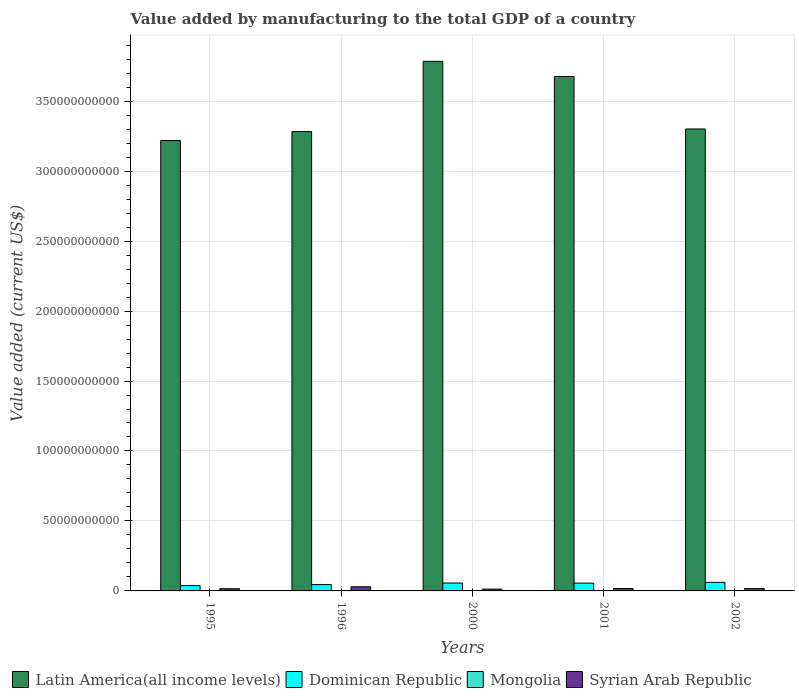How many groups of bars are there?
Provide a short and direct response. 5. What is the label of the 3rd group of bars from the left?
Offer a terse response. 2000. In how many cases, is the number of bars for a given year not equal to the number of legend labels?
Offer a very short reply. 0. What is the value added by manufacturing to the total GDP in Latin America(all income levels) in 1996?
Keep it short and to the point. 3.28e+11. Across all years, what is the maximum value added by manufacturing to the total GDP in Dominican Republic?
Your answer should be very brief. 6.13e+09. Across all years, what is the minimum value added by manufacturing to the total GDP in Syrian Arab Republic?
Provide a short and direct response. 1.29e+09. In which year was the value added by manufacturing to the total GDP in Latin America(all income levels) maximum?
Provide a short and direct response. 2000. In which year was the value added by manufacturing to the total GDP in Dominican Republic minimum?
Offer a terse response. 1995. What is the total value added by manufacturing to the total GDP in Latin America(all income levels) in the graph?
Make the answer very short. 1.73e+12. What is the difference between the value added by manufacturing to the total GDP in Mongolia in 1996 and that in 2001?
Ensure brevity in your answer.  -1.30e+06. What is the difference between the value added by manufacturing to the total GDP in Mongolia in 2000 and the value added by manufacturing to the total GDP in Syrian Arab Republic in 2001?
Your response must be concise. -1.64e+09. What is the average value added by manufacturing to the total GDP in Syrian Arab Republic per year?
Ensure brevity in your answer.  1.84e+09. In the year 1995, what is the difference between the value added by manufacturing to the total GDP in Syrian Arab Republic and value added by manufacturing to the total GDP in Latin America(all income levels)?
Offer a very short reply. -3.20e+11. In how many years, is the value added by manufacturing to the total GDP in Latin America(all income levels) greater than 90000000000 US$?
Keep it short and to the point. 5. What is the ratio of the value added by manufacturing to the total GDP in Syrian Arab Republic in 1996 to that in 2001?
Provide a succinct answer. 1.74. Is the difference between the value added by manufacturing to the total GDP in Syrian Arab Republic in 2001 and 2002 greater than the difference between the value added by manufacturing to the total GDP in Latin America(all income levels) in 2001 and 2002?
Your response must be concise. No. What is the difference between the highest and the second highest value added by manufacturing to the total GDP in Latin America(all income levels)?
Give a very brief answer. 1.08e+1. What is the difference between the highest and the lowest value added by manufacturing to the total GDP in Latin America(all income levels)?
Your answer should be compact. 5.66e+1. In how many years, is the value added by manufacturing to the total GDP in Dominican Republic greater than the average value added by manufacturing to the total GDP in Dominican Republic taken over all years?
Make the answer very short. 3. What does the 2nd bar from the left in 2001 represents?
Offer a very short reply. Dominican Republic. What does the 4th bar from the right in 1996 represents?
Make the answer very short. Latin America(all income levels). Are all the bars in the graph horizontal?
Ensure brevity in your answer.  No. How many years are there in the graph?
Offer a terse response. 5. What is the difference between two consecutive major ticks on the Y-axis?
Make the answer very short. 5.00e+1. Does the graph contain any zero values?
Your answer should be compact. No. How many legend labels are there?
Your response must be concise. 4. What is the title of the graph?
Provide a short and direct response. Value added by manufacturing to the total GDP of a country. What is the label or title of the Y-axis?
Provide a succinct answer. Value added (current US$). What is the Value added (current US$) of Latin America(all income levels) in 1995?
Your response must be concise. 3.22e+11. What is the Value added (current US$) of Dominican Republic in 1995?
Offer a terse response. 3.82e+09. What is the Value added (current US$) of Mongolia in 1995?
Your response must be concise. 2.51e+08. What is the Value added (current US$) in Syrian Arab Republic in 1995?
Keep it short and to the point. 1.57e+09. What is the Value added (current US$) of Latin America(all income levels) in 1996?
Provide a succinct answer. 3.28e+11. What is the Value added (current US$) of Dominican Republic in 1996?
Ensure brevity in your answer.  4.51e+09. What is the Value added (current US$) in Mongolia in 1996?
Provide a short and direct response. 1.03e+08. What is the Value added (current US$) in Syrian Arab Republic in 1996?
Offer a very short reply. 2.97e+09. What is the Value added (current US$) of Latin America(all income levels) in 2000?
Provide a short and direct response. 3.78e+11. What is the Value added (current US$) in Dominican Republic in 2000?
Provide a succinct answer. 5.63e+09. What is the Value added (current US$) in Mongolia in 2000?
Provide a short and direct response. 7.62e+07. What is the Value added (current US$) in Syrian Arab Republic in 2000?
Provide a succinct answer. 1.29e+09. What is the Value added (current US$) in Latin America(all income levels) in 2001?
Offer a terse response. 3.68e+11. What is the Value added (current US$) of Dominican Republic in 2001?
Provide a succinct answer. 5.58e+09. What is the Value added (current US$) in Mongolia in 2001?
Provide a succinct answer. 1.05e+08. What is the Value added (current US$) of Syrian Arab Republic in 2001?
Your answer should be compact. 1.71e+09. What is the Value added (current US$) of Latin America(all income levels) in 2002?
Offer a very short reply. 3.30e+11. What is the Value added (current US$) of Dominican Republic in 2002?
Offer a very short reply. 6.13e+09. What is the Value added (current US$) in Mongolia in 2002?
Provide a succinct answer. 8.93e+07. What is the Value added (current US$) of Syrian Arab Republic in 2002?
Give a very brief answer. 1.65e+09. Across all years, what is the maximum Value added (current US$) of Latin America(all income levels)?
Offer a terse response. 3.78e+11. Across all years, what is the maximum Value added (current US$) of Dominican Republic?
Your answer should be very brief. 6.13e+09. Across all years, what is the maximum Value added (current US$) of Mongolia?
Your answer should be very brief. 2.51e+08. Across all years, what is the maximum Value added (current US$) of Syrian Arab Republic?
Make the answer very short. 2.97e+09. Across all years, what is the minimum Value added (current US$) in Latin America(all income levels)?
Keep it short and to the point. 3.22e+11. Across all years, what is the minimum Value added (current US$) of Dominican Republic?
Your answer should be compact. 3.82e+09. Across all years, what is the minimum Value added (current US$) of Mongolia?
Your answer should be very brief. 7.62e+07. Across all years, what is the minimum Value added (current US$) in Syrian Arab Republic?
Offer a terse response. 1.29e+09. What is the total Value added (current US$) of Latin America(all income levels) in the graph?
Keep it short and to the point. 1.73e+12. What is the total Value added (current US$) in Dominican Republic in the graph?
Ensure brevity in your answer.  2.57e+1. What is the total Value added (current US$) in Mongolia in the graph?
Keep it short and to the point. 6.24e+08. What is the total Value added (current US$) in Syrian Arab Republic in the graph?
Your answer should be very brief. 9.20e+09. What is the difference between the Value added (current US$) of Latin America(all income levels) in 1995 and that in 1996?
Your answer should be compact. -6.43e+09. What is the difference between the Value added (current US$) in Dominican Republic in 1995 and that in 1996?
Provide a succinct answer. -6.84e+08. What is the difference between the Value added (current US$) in Mongolia in 1995 and that in 1996?
Provide a short and direct response. 1.48e+08. What is the difference between the Value added (current US$) in Syrian Arab Republic in 1995 and that in 1996?
Make the answer very short. -1.40e+09. What is the difference between the Value added (current US$) of Latin America(all income levels) in 1995 and that in 2000?
Ensure brevity in your answer.  -5.66e+1. What is the difference between the Value added (current US$) of Dominican Republic in 1995 and that in 2000?
Give a very brief answer. -1.81e+09. What is the difference between the Value added (current US$) of Mongolia in 1995 and that in 2000?
Make the answer very short. 1.75e+08. What is the difference between the Value added (current US$) of Syrian Arab Republic in 1995 and that in 2000?
Offer a terse response. 2.88e+08. What is the difference between the Value added (current US$) of Latin America(all income levels) in 1995 and that in 2001?
Give a very brief answer. -4.58e+1. What is the difference between the Value added (current US$) of Dominican Republic in 1995 and that in 2001?
Your answer should be very brief. -1.75e+09. What is the difference between the Value added (current US$) of Mongolia in 1995 and that in 2001?
Keep it short and to the point. 1.46e+08. What is the difference between the Value added (current US$) of Syrian Arab Republic in 1995 and that in 2001?
Provide a short and direct response. -1.39e+08. What is the difference between the Value added (current US$) of Latin America(all income levels) in 1995 and that in 2002?
Your answer should be very brief. -8.28e+09. What is the difference between the Value added (current US$) of Dominican Republic in 1995 and that in 2002?
Provide a short and direct response. -2.30e+09. What is the difference between the Value added (current US$) in Mongolia in 1995 and that in 2002?
Give a very brief answer. 1.62e+08. What is the difference between the Value added (current US$) of Syrian Arab Republic in 1995 and that in 2002?
Provide a succinct answer. -7.89e+07. What is the difference between the Value added (current US$) of Latin America(all income levels) in 1996 and that in 2000?
Give a very brief answer. -5.02e+1. What is the difference between the Value added (current US$) in Dominican Republic in 1996 and that in 2000?
Ensure brevity in your answer.  -1.13e+09. What is the difference between the Value added (current US$) of Mongolia in 1996 and that in 2000?
Offer a very short reply. 2.71e+07. What is the difference between the Value added (current US$) of Syrian Arab Republic in 1996 and that in 2000?
Your answer should be very brief. 1.69e+09. What is the difference between the Value added (current US$) of Latin America(all income levels) in 1996 and that in 2001?
Ensure brevity in your answer.  -3.94e+1. What is the difference between the Value added (current US$) in Dominican Republic in 1996 and that in 2001?
Provide a succinct answer. -1.07e+09. What is the difference between the Value added (current US$) in Mongolia in 1996 and that in 2001?
Your answer should be compact. -1.30e+06. What is the difference between the Value added (current US$) in Syrian Arab Republic in 1996 and that in 2001?
Make the answer very short. 1.26e+09. What is the difference between the Value added (current US$) of Latin America(all income levels) in 1996 and that in 2002?
Your response must be concise. -1.86e+09. What is the difference between the Value added (current US$) in Dominican Republic in 1996 and that in 2002?
Offer a very short reply. -1.62e+09. What is the difference between the Value added (current US$) in Mongolia in 1996 and that in 2002?
Provide a short and direct response. 1.40e+07. What is the difference between the Value added (current US$) in Syrian Arab Republic in 1996 and that in 2002?
Keep it short and to the point. 1.32e+09. What is the difference between the Value added (current US$) of Latin America(all income levels) in 2000 and that in 2001?
Your response must be concise. 1.08e+1. What is the difference between the Value added (current US$) in Dominican Republic in 2000 and that in 2001?
Provide a short and direct response. 5.89e+07. What is the difference between the Value added (current US$) in Mongolia in 2000 and that in 2001?
Your response must be concise. -2.84e+07. What is the difference between the Value added (current US$) of Syrian Arab Republic in 2000 and that in 2001?
Ensure brevity in your answer.  -4.27e+08. What is the difference between the Value added (current US$) in Latin America(all income levels) in 2000 and that in 2002?
Your answer should be very brief. 4.83e+1. What is the difference between the Value added (current US$) of Dominican Republic in 2000 and that in 2002?
Provide a short and direct response. -4.93e+08. What is the difference between the Value added (current US$) of Mongolia in 2000 and that in 2002?
Provide a succinct answer. -1.31e+07. What is the difference between the Value added (current US$) in Syrian Arab Republic in 2000 and that in 2002?
Your answer should be very brief. -3.67e+08. What is the difference between the Value added (current US$) in Latin America(all income levels) in 2001 and that in 2002?
Offer a terse response. 3.75e+1. What is the difference between the Value added (current US$) of Dominican Republic in 2001 and that in 2002?
Make the answer very short. -5.52e+08. What is the difference between the Value added (current US$) of Mongolia in 2001 and that in 2002?
Provide a short and direct response. 1.53e+07. What is the difference between the Value added (current US$) in Syrian Arab Republic in 2001 and that in 2002?
Your answer should be very brief. 6.00e+07. What is the difference between the Value added (current US$) of Latin America(all income levels) in 1995 and the Value added (current US$) of Dominican Republic in 1996?
Offer a terse response. 3.17e+11. What is the difference between the Value added (current US$) in Latin America(all income levels) in 1995 and the Value added (current US$) in Mongolia in 1996?
Give a very brief answer. 3.22e+11. What is the difference between the Value added (current US$) in Latin America(all income levels) in 1995 and the Value added (current US$) in Syrian Arab Republic in 1996?
Offer a terse response. 3.19e+11. What is the difference between the Value added (current US$) in Dominican Republic in 1995 and the Value added (current US$) in Mongolia in 1996?
Your answer should be very brief. 3.72e+09. What is the difference between the Value added (current US$) of Dominican Republic in 1995 and the Value added (current US$) of Syrian Arab Republic in 1996?
Your answer should be very brief. 8.49e+08. What is the difference between the Value added (current US$) in Mongolia in 1995 and the Value added (current US$) in Syrian Arab Republic in 1996?
Provide a succinct answer. -2.72e+09. What is the difference between the Value added (current US$) in Latin America(all income levels) in 1995 and the Value added (current US$) in Dominican Republic in 2000?
Your answer should be compact. 3.16e+11. What is the difference between the Value added (current US$) in Latin America(all income levels) in 1995 and the Value added (current US$) in Mongolia in 2000?
Make the answer very short. 3.22e+11. What is the difference between the Value added (current US$) in Latin America(all income levels) in 1995 and the Value added (current US$) in Syrian Arab Republic in 2000?
Offer a very short reply. 3.21e+11. What is the difference between the Value added (current US$) in Dominican Republic in 1995 and the Value added (current US$) in Mongolia in 2000?
Offer a very short reply. 3.75e+09. What is the difference between the Value added (current US$) in Dominican Republic in 1995 and the Value added (current US$) in Syrian Arab Republic in 2000?
Make the answer very short. 2.54e+09. What is the difference between the Value added (current US$) in Mongolia in 1995 and the Value added (current US$) in Syrian Arab Republic in 2000?
Provide a short and direct response. -1.04e+09. What is the difference between the Value added (current US$) of Latin America(all income levels) in 1995 and the Value added (current US$) of Dominican Republic in 2001?
Offer a terse response. 3.16e+11. What is the difference between the Value added (current US$) in Latin America(all income levels) in 1995 and the Value added (current US$) in Mongolia in 2001?
Offer a terse response. 3.22e+11. What is the difference between the Value added (current US$) of Latin America(all income levels) in 1995 and the Value added (current US$) of Syrian Arab Republic in 2001?
Your answer should be compact. 3.20e+11. What is the difference between the Value added (current US$) of Dominican Republic in 1995 and the Value added (current US$) of Mongolia in 2001?
Make the answer very short. 3.72e+09. What is the difference between the Value added (current US$) of Dominican Republic in 1995 and the Value added (current US$) of Syrian Arab Republic in 2001?
Make the answer very short. 2.11e+09. What is the difference between the Value added (current US$) of Mongolia in 1995 and the Value added (current US$) of Syrian Arab Republic in 2001?
Provide a short and direct response. -1.46e+09. What is the difference between the Value added (current US$) of Latin America(all income levels) in 1995 and the Value added (current US$) of Dominican Republic in 2002?
Make the answer very short. 3.16e+11. What is the difference between the Value added (current US$) in Latin America(all income levels) in 1995 and the Value added (current US$) in Mongolia in 2002?
Your response must be concise. 3.22e+11. What is the difference between the Value added (current US$) in Latin America(all income levels) in 1995 and the Value added (current US$) in Syrian Arab Republic in 2002?
Make the answer very short. 3.20e+11. What is the difference between the Value added (current US$) in Dominican Republic in 1995 and the Value added (current US$) in Mongolia in 2002?
Your answer should be very brief. 3.73e+09. What is the difference between the Value added (current US$) in Dominican Republic in 1995 and the Value added (current US$) in Syrian Arab Republic in 2002?
Your answer should be very brief. 2.17e+09. What is the difference between the Value added (current US$) of Mongolia in 1995 and the Value added (current US$) of Syrian Arab Republic in 2002?
Keep it short and to the point. -1.40e+09. What is the difference between the Value added (current US$) of Latin America(all income levels) in 1996 and the Value added (current US$) of Dominican Republic in 2000?
Provide a short and direct response. 3.23e+11. What is the difference between the Value added (current US$) in Latin America(all income levels) in 1996 and the Value added (current US$) in Mongolia in 2000?
Your response must be concise. 3.28e+11. What is the difference between the Value added (current US$) in Latin America(all income levels) in 1996 and the Value added (current US$) in Syrian Arab Republic in 2000?
Keep it short and to the point. 3.27e+11. What is the difference between the Value added (current US$) in Dominican Republic in 1996 and the Value added (current US$) in Mongolia in 2000?
Keep it short and to the point. 4.43e+09. What is the difference between the Value added (current US$) of Dominican Republic in 1996 and the Value added (current US$) of Syrian Arab Republic in 2000?
Your answer should be compact. 3.22e+09. What is the difference between the Value added (current US$) in Mongolia in 1996 and the Value added (current US$) in Syrian Arab Republic in 2000?
Keep it short and to the point. -1.18e+09. What is the difference between the Value added (current US$) in Latin America(all income levels) in 1996 and the Value added (current US$) in Dominican Republic in 2001?
Your answer should be very brief. 3.23e+11. What is the difference between the Value added (current US$) in Latin America(all income levels) in 1996 and the Value added (current US$) in Mongolia in 2001?
Provide a succinct answer. 3.28e+11. What is the difference between the Value added (current US$) in Latin America(all income levels) in 1996 and the Value added (current US$) in Syrian Arab Republic in 2001?
Provide a short and direct response. 3.27e+11. What is the difference between the Value added (current US$) of Dominican Republic in 1996 and the Value added (current US$) of Mongolia in 2001?
Your answer should be compact. 4.40e+09. What is the difference between the Value added (current US$) of Dominican Republic in 1996 and the Value added (current US$) of Syrian Arab Republic in 2001?
Provide a short and direct response. 2.79e+09. What is the difference between the Value added (current US$) in Mongolia in 1996 and the Value added (current US$) in Syrian Arab Republic in 2001?
Your response must be concise. -1.61e+09. What is the difference between the Value added (current US$) in Latin America(all income levels) in 1996 and the Value added (current US$) in Dominican Republic in 2002?
Make the answer very short. 3.22e+11. What is the difference between the Value added (current US$) in Latin America(all income levels) in 1996 and the Value added (current US$) in Mongolia in 2002?
Offer a very short reply. 3.28e+11. What is the difference between the Value added (current US$) in Latin America(all income levels) in 1996 and the Value added (current US$) in Syrian Arab Republic in 2002?
Keep it short and to the point. 3.27e+11. What is the difference between the Value added (current US$) of Dominican Republic in 1996 and the Value added (current US$) of Mongolia in 2002?
Offer a terse response. 4.42e+09. What is the difference between the Value added (current US$) of Dominican Republic in 1996 and the Value added (current US$) of Syrian Arab Republic in 2002?
Provide a succinct answer. 2.85e+09. What is the difference between the Value added (current US$) in Mongolia in 1996 and the Value added (current US$) in Syrian Arab Republic in 2002?
Keep it short and to the point. -1.55e+09. What is the difference between the Value added (current US$) of Latin America(all income levels) in 2000 and the Value added (current US$) of Dominican Republic in 2001?
Keep it short and to the point. 3.73e+11. What is the difference between the Value added (current US$) in Latin America(all income levels) in 2000 and the Value added (current US$) in Mongolia in 2001?
Offer a very short reply. 3.78e+11. What is the difference between the Value added (current US$) of Latin America(all income levels) in 2000 and the Value added (current US$) of Syrian Arab Republic in 2001?
Ensure brevity in your answer.  3.77e+11. What is the difference between the Value added (current US$) in Dominican Republic in 2000 and the Value added (current US$) in Mongolia in 2001?
Your response must be concise. 5.53e+09. What is the difference between the Value added (current US$) in Dominican Republic in 2000 and the Value added (current US$) in Syrian Arab Republic in 2001?
Offer a terse response. 3.92e+09. What is the difference between the Value added (current US$) in Mongolia in 2000 and the Value added (current US$) in Syrian Arab Republic in 2001?
Give a very brief answer. -1.64e+09. What is the difference between the Value added (current US$) in Latin America(all income levels) in 2000 and the Value added (current US$) in Dominican Republic in 2002?
Your answer should be very brief. 3.72e+11. What is the difference between the Value added (current US$) in Latin America(all income levels) in 2000 and the Value added (current US$) in Mongolia in 2002?
Provide a succinct answer. 3.78e+11. What is the difference between the Value added (current US$) of Latin America(all income levels) in 2000 and the Value added (current US$) of Syrian Arab Republic in 2002?
Your response must be concise. 3.77e+11. What is the difference between the Value added (current US$) of Dominican Republic in 2000 and the Value added (current US$) of Mongolia in 2002?
Ensure brevity in your answer.  5.55e+09. What is the difference between the Value added (current US$) in Dominican Republic in 2000 and the Value added (current US$) in Syrian Arab Republic in 2002?
Ensure brevity in your answer.  3.98e+09. What is the difference between the Value added (current US$) in Mongolia in 2000 and the Value added (current US$) in Syrian Arab Republic in 2002?
Your answer should be compact. -1.58e+09. What is the difference between the Value added (current US$) in Latin America(all income levels) in 2001 and the Value added (current US$) in Dominican Republic in 2002?
Provide a succinct answer. 3.61e+11. What is the difference between the Value added (current US$) in Latin America(all income levels) in 2001 and the Value added (current US$) in Mongolia in 2002?
Your answer should be very brief. 3.68e+11. What is the difference between the Value added (current US$) in Latin America(all income levels) in 2001 and the Value added (current US$) in Syrian Arab Republic in 2002?
Give a very brief answer. 3.66e+11. What is the difference between the Value added (current US$) in Dominican Republic in 2001 and the Value added (current US$) in Mongolia in 2002?
Make the answer very short. 5.49e+09. What is the difference between the Value added (current US$) of Dominican Republic in 2001 and the Value added (current US$) of Syrian Arab Republic in 2002?
Your answer should be compact. 3.92e+09. What is the difference between the Value added (current US$) in Mongolia in 2001 and the Value added (current US$) in Syrian Arab Republic in 2002?
Your response must be concise. -1.55e+09. What is the average Value added (current US$) in Latin America(all income levels) per year?
Your answer should be very brief. 3.45e+11. What is the average Value added (current US$) of Dominican Republic per year?
Ensure brevity in your answer.  5.13e+09. What is the average Value added (current US$) in Mongolia per year?
Your answer should be compact. 1.25e+08. What is the average Value added (current US$) of Syrian Arab Republic per year?
Give a very brief answer. 1.84e+09. In the year 1995, what is the difference between the Value added (current US$) of Latin America(all income levels) and Value added (current US$) of Dominican Republic?
Your response must be concise. 3.18e+11. In the year 1995, what is the difference between the Value added (current US$) of Latin America(all income levels) and Value added (current US$) of Mongolia?
Your response must be concise. 3.22e+11. In the year 1995, what is the difference between the Value added (current US$) in Latin America(all income levels) and Value added (current US$) in Syrian Arab Republic?
Provide a succinct answer. 3.20e+11. In the year 1995, what is the difference between the Value added (current US$) of Dominican Republic and Value added (current US$) of Mongolia?
Make the answer very short. 3.57e+09. In the year 1995, what is the difference between the Value added (current US$) in Dominican Republic and Value added (current US$) in Syrian Arab Republic?
Make the answer very short. 2.25e+09. In the year 1995, what is the difference between the Value added (current US$) of Mongolia and Value added (current US$) of Syrian Arab Republic?
Your answer should be very brief. -1.32e+09. In the year 1996, what is the difference between the Value added (current US$) in Latin America(all income levels) and Value added (current US$) in Dominican Republic?
Keep it short and to the point. 3.24e+11. In the year 1996, what is the difference between the Value added (current US$) in Latin America(all income levels) and Value added (current US$) in Mongolia?
Keep it short and to the point. 3.28e+11. In the year 1996, what is the difference between the Value added (current US$) of Latin America(all income levels) and Value added (current US$) of Syrian Arab Republic?
Offer a terse response. 3.25e+11. In the year 1996, what is the difference between the Value added (current US$) of Dominican Republic and Value added (current US$) of Mongolia?
Offer a terse response. 4.40e+09. In the year 1996, what is the difference between the Value added (current US$) in Dominican Republic and Value added (current US$) in Syrian Arab Republic?
Provide a succinct answer. 1.53e+09. In the year 1996, what is the difference between the Value added (current US$) in Mongolia and Value added (current US$) in Syrian Arab Republic?
Make the answer very short. -2.87e+09. In the year 2000, what is the difference between the Value added (current US$) of Latin America(all income levels) and Value added (current US$) of Dominican Republic?
Keep it short and to the point. 3.73e+11. In the year 2000, what is the difference between the Value added (current US$) in Latin America(all income levels) and Value added (current US$) in Mongolia?
Your answer should be compact. 3.78e+11. In the year 2000, what is the difference between the Value added (current US$) of Latin America(all income levels) and Value added (current US$) of Syrian Arab Republic?
Provide a short and direct response. 3.77e+11. In the year 2000, what is the difference between the Value added (current US$) in Dominican Republic and Value added (current US$) in Mongolia?
Provide a short and direct response. 5.56e+09. In the year 2000, what is the difference between the Value added (current US$) in Dominican Republic and Value added (current US$) in Syrian Arab Republic?
Give a very brief answer. 4.35e+09. In the year 2000, what is the difference between the Value added (current US$) of Mongolia and Value added (current US$) of Syrian Arab Republic?
Provide a succinct answer. -1.21e+09. In the year 2001, what is the difference between the Value added (current US$) of Latin America(all income levels) and Value added (current US$) of Dominican Republic?
Give a very brief answer. 3.62e+11. In the year 2001, what is the difference between the Value added (current US$) in Latin America(all income levels) and Value added (current US$) in Mongolia?
Ensure brevity in your answer.  3.68e+11. In the year 2001, what is the difference between the Value added (current US$) in Latin America(all income levels) and Value added (current US$) in Syrian Arab Republic?
Offer a terse response. 3.66e+11. In the year 2001, what is the difference between the Value added (current US$) in Dominican Republic and Value added (current US$) in Mongolia?
Provide a succinct answer. 5.47e+09. In the year 2001, what is the difference between the Value added (current US$) in Dominican Republic and Value added (current US$) in Syrian Arab Republic?
Keep it short and to the point. 3.86e+09. In the year 2001, what is the difference between the Value added (current US$) in Mongolia and Value added (current US$) in Syrian Arab Republic?
Your answer should be compact. -1.61e+09. In the year 2002, what is the difference between the Value added (current US$) of Latin America(all income levels) and Value added (current US$) of Dominican Republic?
Make the answer very short. 3.24e+11. In the year 2002, what is the difference between the Value added (current US$) in Latin America(all income levels) and Value added (current US$) in Mongolia?
Give a very brief answer. 3.30e+11. In the year 2002, what is the difference between the Value added (current US$) of Latin America(all income levels) and Value added (current US$) of Syrian Arab Republic?
Your response must be concise. 3.28e+11. In the year 2002, what is the difference between the Value added (current US$) of Dominican Republic and Value added (current US$) of Mongolia?
Your answer should be very brief. 6.04e+09. In the year 2002, what is the difference between the Value added (current US$) in Dominican Republic and Value added (current US$) in Syrian Arab Republic?
Offer a very short reply. 4.47e+09. In the year 2002, what is the difference between the Value added (current US$) of Mongolia and Value added (current US$) of Syrian Arab Republic?
Offer a very short reply. -1.56e+09. What is the ratio of the Value added (current US$) of Latin America(all income levels) in 1995 to that in 1996?
Keep it short and to the point. 0.98. What is the ratio of the Value added (current US$) of Dominican Republic in 1995 to that in 1996?
Provide a succinct answer. 0.85. What is the ratio of the Value added (current US$) in Mongolia in 1995 to that in 1996?
Make the answer very short. 2.43. What is the ratio of the Value added (current US$) in Syrian Arab Republic in 1995 to that in 1996?
Offer a very short reply. 0.53. What is the ratio of the Value added (current US$) of Latin America(all income levels) in 1995 to that in 2000?
Provide a succinct answer. 0.85. What is the ratio of the Value added (current US$) of Dominican Republic in 1995 to that in 2000?
Keep it short and to the point. 0.68. What is the ratio of the Value added (current US$) of Mongolia in 1995 to that in 2000?
Give a very brief answer. 3.29. What is the ratio of the Value added (current US$) in Syrian Arab Republic in 1995 to that in 2000?
Ensure brevity in your answer.  1.22. What is the ratio of the Value added (current US$) in Latin America(all income levels) in 1995 to that in 2001?
Your response must be concise. 0.88. What is the ratio of the Value added (current US$) in Dominican Republic in 1995 to that in 2001?
Give a very brief answer. 0.69. What is the ratio of the Value added (current US$) in Mongolia in 1995 to that in 2001?
Provide a short and direct response. 2.4. What is the ratio of the Value added (current US$) of Syrian Arab Republic in 1995 to that in 2001?
Provide a short and direct response. 0.92. What is the ratio of the Value added (current US$) in Latin America(all income levels) in 1995 to that in 2002?
Offer a terse response. 0.97. What is the ratio of the Value added (current US$) in Dominican Republic in 1995 to that in 2002?
Give a very brief answer. 0.62. What is the ratio of the Value added (current US$) of Mongolia in 1995 to that in 2002?
Make the answer very short. 2.81. What is the ratio of the Value added (current US$) of Syrian Arab Republic in 1995 to that in 2002?
Offer a terse response. 0.95. What is the ratio of the Value added (current US$) in Latin America(all income levels) in 1996 to that in 2000?
Your answer should be compact. 0.87. What is the ratio of the Value added (current US$) of Dominican Republic in 1996 to that in 2000?
Offer a very short reply. 0.8. What is the ratio of the Value added (current US$) in Mongolia in 1996 to that in 2000?
Give a very brief answer. 1.36. What is the ratio of the Value added (current US$) of Syrian Arab Republic in 1996 to that in 2000?
Provide a succinct answer. 2.31. What is the ratio of the Value added (current US$) in Latin America(all income levels) in 1996 to that in 2001?
Offer a very short reply. 0.89. What is the ratio of the Value added (current US$) of Dominican Republic in 1996 to that in 2001?
Your answer should be compact. 0.81. What is the ratio of the Value added (current US$) in Mongolia in 1996 to that in 2001?
Your answer should be very brief. 0.99. What is the ratio of the Value added (current US$) of Syrian Arab Republic in 1996 to that in 2001?
Make the answer very short. 1.74. What is the ratio of the Value added (current US$) in Dominican Republic in 1996 to that in 2002?
Ensure brevity in your answer.  0.74. What is the ratio of the Value added (current US$) of Mongolia in 1996 to that in 2002?
Ensure brevity in your answer.  1.16. What is the ratio of the Value added (current US$) in Syrian Arab Republic in 1996 to that in 2002?
Offer a very short reply. 1.8. What is the ratio of the Value added (current US$) of Latin America(all income levels) in 2000 to that in 2001?
Keep it short and to the point. 1.03. What is the ratio of the Value added (current US$) in Dominican Republic in 2000 to that in 2001?
Give a very brief answer. 1.01. What is the ratio of the Value added (current US$) of Mongolia in 2000 to that in 2001?
Make the answer very short. 0.73. What is the ratio of the Value added (current US$) of Syrian Arab Republic in 2000 to that in 2001?
Give a very brief answer. 0.75. What is the ratio of the Value added (current US$) of Latin America(all income levels) in 2000 to that in 2002?
Offer a very short reply. 1.15. What is the ratio of the Value added (current US$) of Dominican Republic in 2000 to that in 2002?
Give a very brief answer. 0.92. What is the ratio of the Value added (current US$) of Mongolia in 2000 to that in 2002?
Give a very brief answer. 0.85. What is the ratio of the Value added (current US$) of Syrian Arab Republic in 2000 to that in 2002?
Your answer should be compact. 0.78. What is the ratio of the Value added (current US$) in Latin America(all income levels) in 2001 to that in 2002?
Offer a very short reply. 1.11. What is the ratio of the Value added (current US$) of Dominican Republic in 2001 to that in 2002?
Provide a short and direct response. 0.91. What is the ratio of the Value added (current US$) in Mongolia in 2001 to that in 2002?
Keep it short and to the point. 1.17. What is the ratio of the Value added (current US$) of Syrian Arab Republic in 2001 to that in 2002?
Offer a very short reply. 1.04. What is the difference between the highest and the second highest Value added (current US$) of Latin America(all income levels)?
Give a very brief answer. 1.08e+1. What is the difference between the highest and the second highest Value added (current US$) of Dominican Republic?
Keep it short and to the point. 4.93e+08. What is the difference between the highest and the second highest Value added (current US$) in Mongolia?
Make the answer very short. 1.46e+08. What is the difference between the highest and the second highest Value added (current US$) in Syrian Arab Republic?
Keep it short and to the point. 1.26e+09. What is the difference between the highest and the lowest Value added (current US$) of Latin America(all income levels)?
Give a very brief answer. 5.66e+1. What is the difference between the highest and the lowest Value added (current US$) in Dominican Republic?
Make the answer very short. 2.30e+09. What is the difference between the highest and the lowest Value added (current US$) of Mongolia?
Your answer should be compact. 1.75e+08. What is the difference between the highest and the lowest Value added (current US$) of Syrian Arab Republic?
Ensure brevity in your answer.  1.69e+09. 